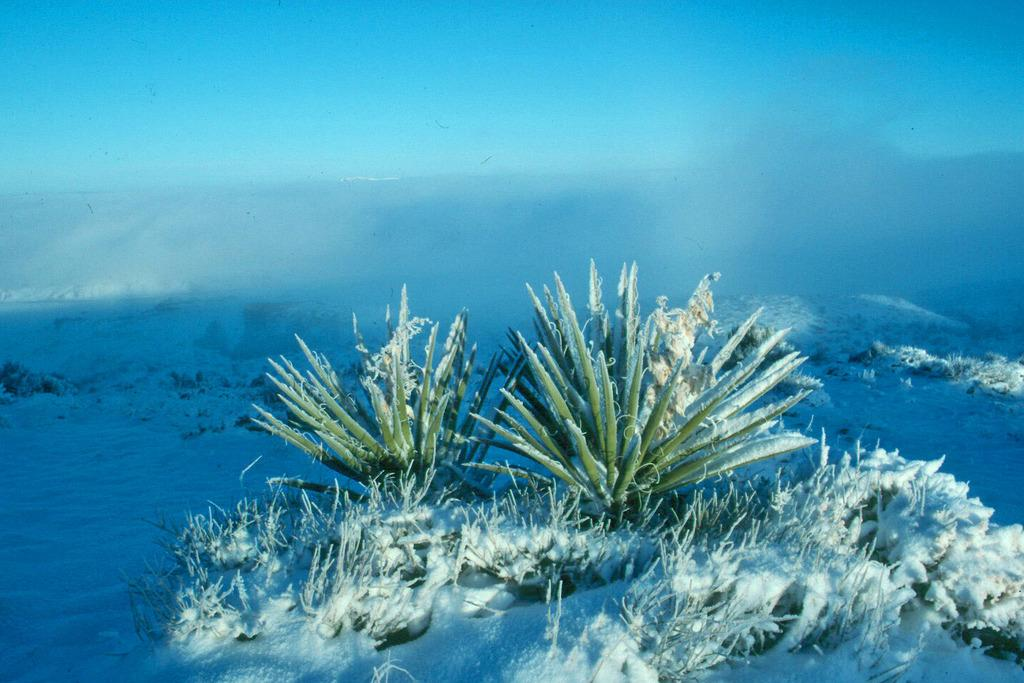What type of vegetation is present in the image? There are plants in the image. What is the weather condition in the image? There is snow in the image, indicating a cold and likely wintery condition. What can be seen in the background of the image? The sky is visible in the background of the image. What type of chalk is being used to draw on the snow in the image? There is no chalk or drawing activity present in the image. How does the shock of the cold weather affect the plants in the image? The image does not show any signs of shock or distress in the plants due to the cold weather. 